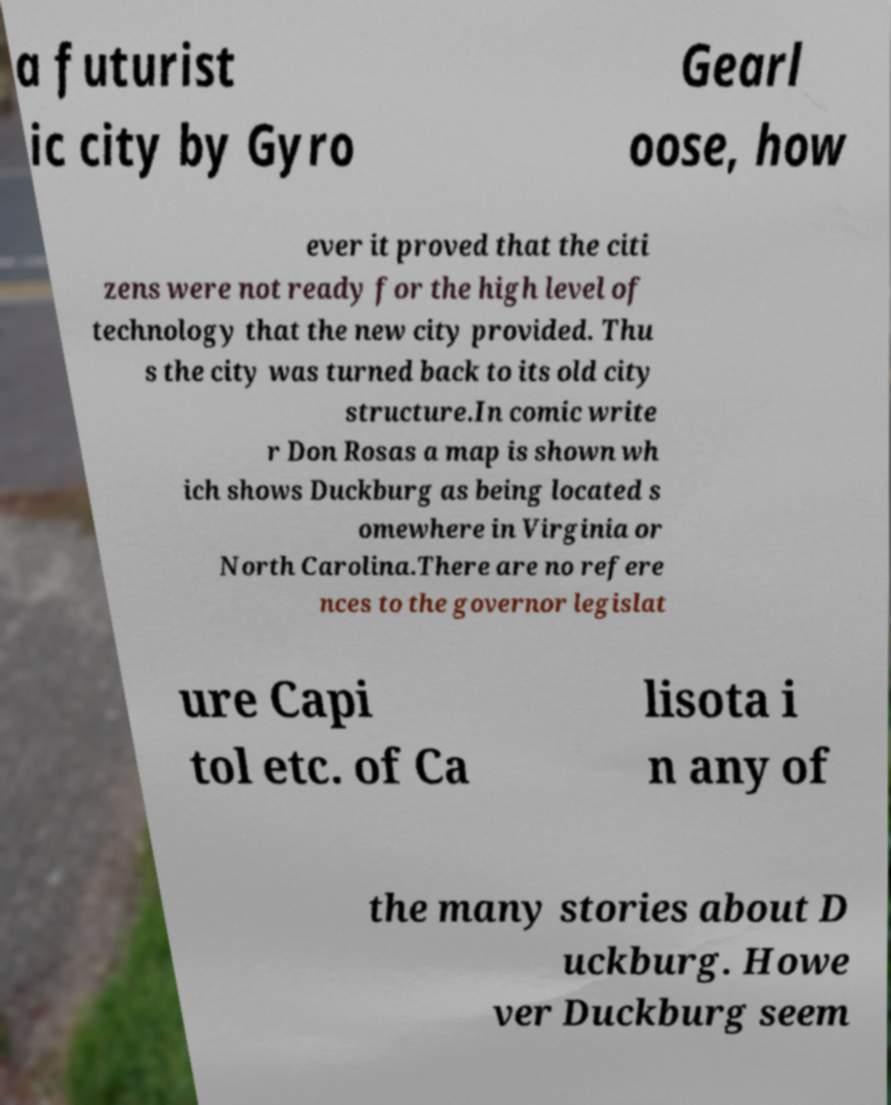For documentation purposes, I need the text within this image transcribed. Could you provide that? a futurist ic city by Gyro Gearl oose, how ever it proved that the citi zens were not ready for the high level of technology that the new city provided. Thu s the city was turned back to its old city structure.In comic write r Don Rosas a map is shown wh ich shows Duckburg as being located s omewhere in Virginia or North Carolina.There are no refere nces to the governor legislat ure Capi tol etc. of Ca lisota i n any of the many stories about D uckburg. Howe ver Duckburg seem 